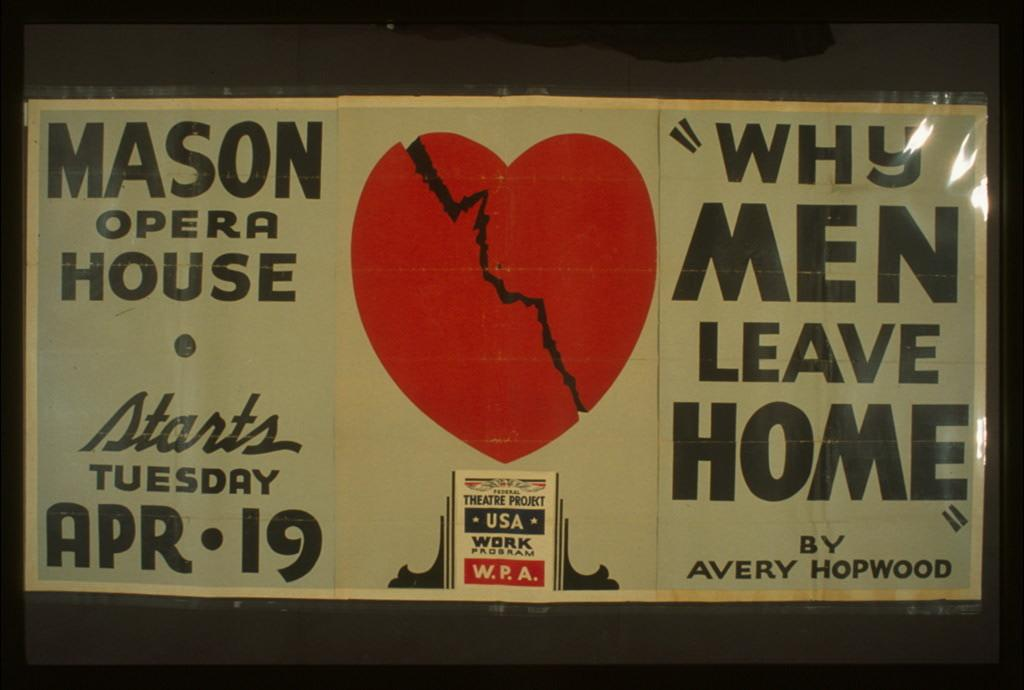<image>
Write a terse but informative summary of the picture. a white sign with black writing and a red heart in the middle for the mason opera house 